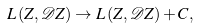Convert formula to latex. <formula><loc_0><loc_0><loc_500><loc_500>L \left ( Z , \mathcal { D } Z \right ) \rightarrow L \left ( Z , \mathcal { D } Z \right ) + C ,</formula> 